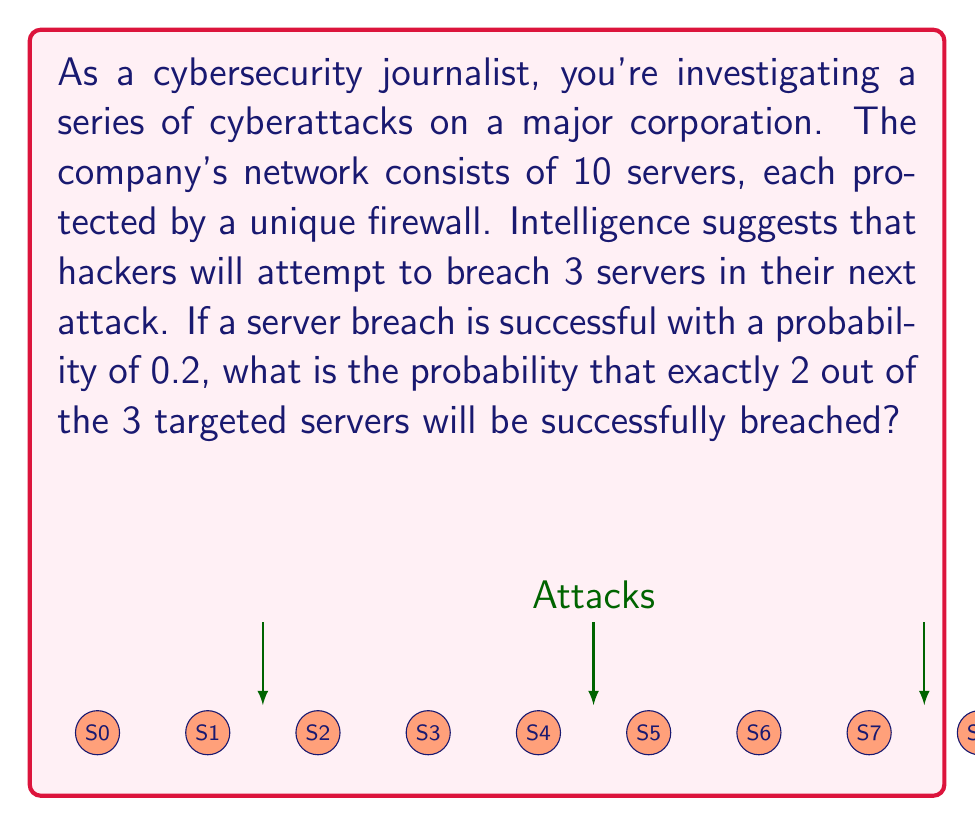Help me with this question. Let's approach this step-by-step using combinatorics and probability theory:

1) This scenario follows a binomial probability distribution. We have a fixed number of independent trials (3 server attacks), each with the same probability of success (0.2).

2) We want the probability of exactly 2 successes out of 3 trials. The binomial probability formula is:

   $$P(X = k) = \binom{n}{k} p^k (1-p)^{n-k}$$

   Where:
   $n$ = number of trials (3)
   $k$ = number of successes (2)
   $p$ = probability of success on each trial (0.2)

3) Let's calculate each part:

   a) $\binom{n}{k} = \binom{3}{2} = \frac{3!}{2!(3-2)!} = 3$

   b) $p^k = 0.2^2 = 0.04$

   c) $(1-p)^{n-k} = (1-0.2)^{3-2} = 0.8^1 = 0.8$

4) Now, let's put it all together:

   $$P(X = 2) = 3 \times 0.04 \times 0.8 = 0.096$$

5) Therefore, the probability of exactly 2 out of 3 targeted servers being successfully breached is 0.096 or 9.6%.
Answer: 0.096 